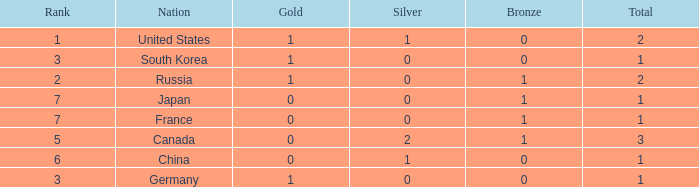Which Rank has a Nation of south korea, and a Silver larger than 0? None. 